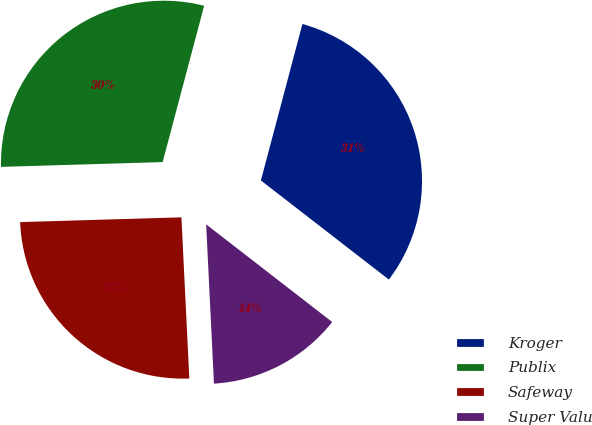Convert chart. <chart><loc_0><loc_0><loc_500><loc_500><pie_chart><fcel>Kroger<fcel>Publix<fcel>Safeway<fcel>Super Valu<nl><fcel>31.36%<fcel>29.6%<fcel>25.31%<fcel>13.73%<nl></chart> 